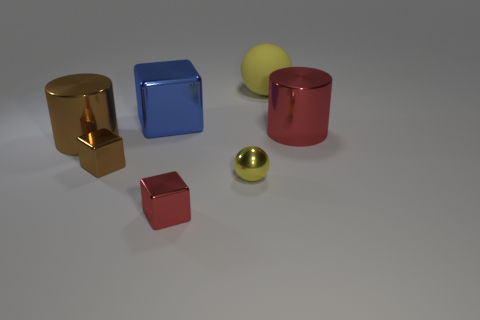Add 3 large blocks. How many objects exist? 10 Subtract all cylinders. How many objects are left? 5 Add 1 large matte spheres. How many large matte spheres exist? 2 Subtract 1 red cylinders. How many objects are left? 6 Subtract all blue spheres. Subtract all big blocks. How many objects are left? 6 Add 2 shiny cylinders. How many shiny cylinders are left? 4 